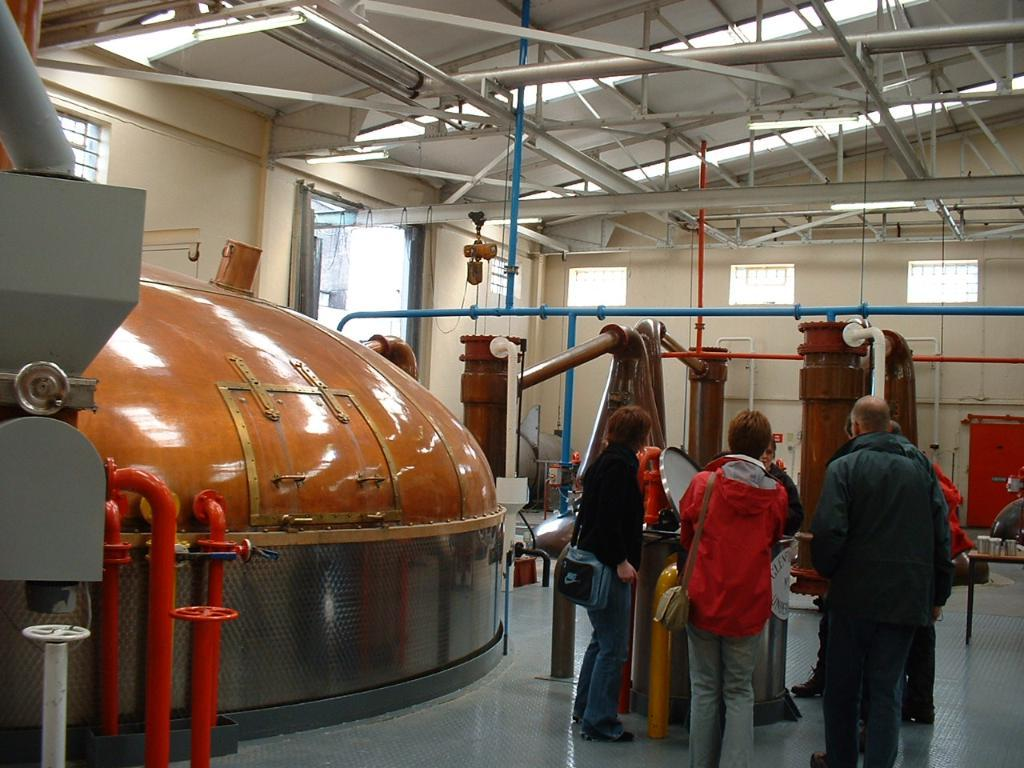What are the people in the image doing? The people in the image are standing on the floor. What are the bags being used for in the image? Two people are wearing bags, which might be used for carrying items. What can be seen in the background of the image? There is a wall in the image. What type of objects can be seen in the image? Metal objects are present in the image. Can you describe any other objects visible in the image? There are other objects visible in the image, but their specific details are not mentioned in the provided facts. What type of paste is being used by the friends in the image? There is no mention of friends or paste in the provided facts, so we cannot answer this question based on the image. 